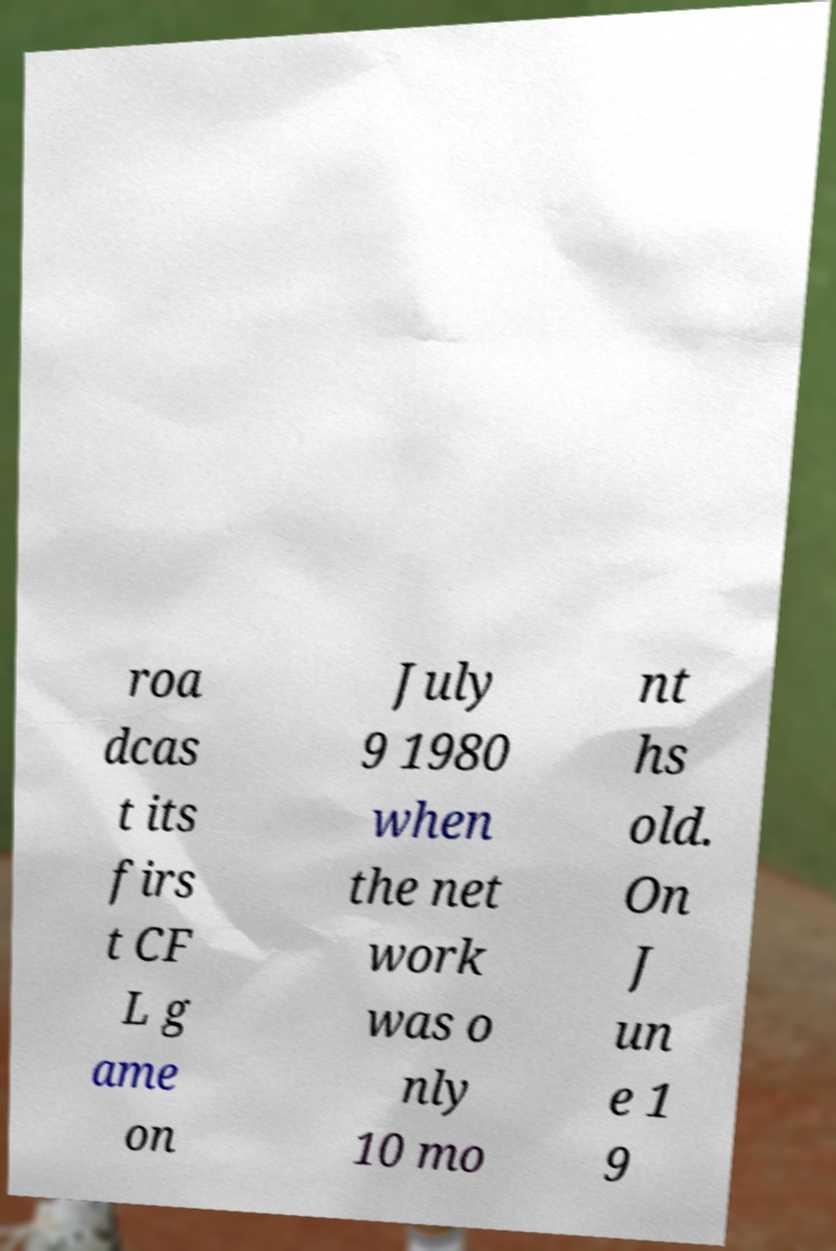Could you assist in decoding the text presented in this image and type it out clearly? roa dcas t its firs t CF L g ame on July 9 1980 when the net work was o nly 10 mo nt hs old. On J un e 1 9 